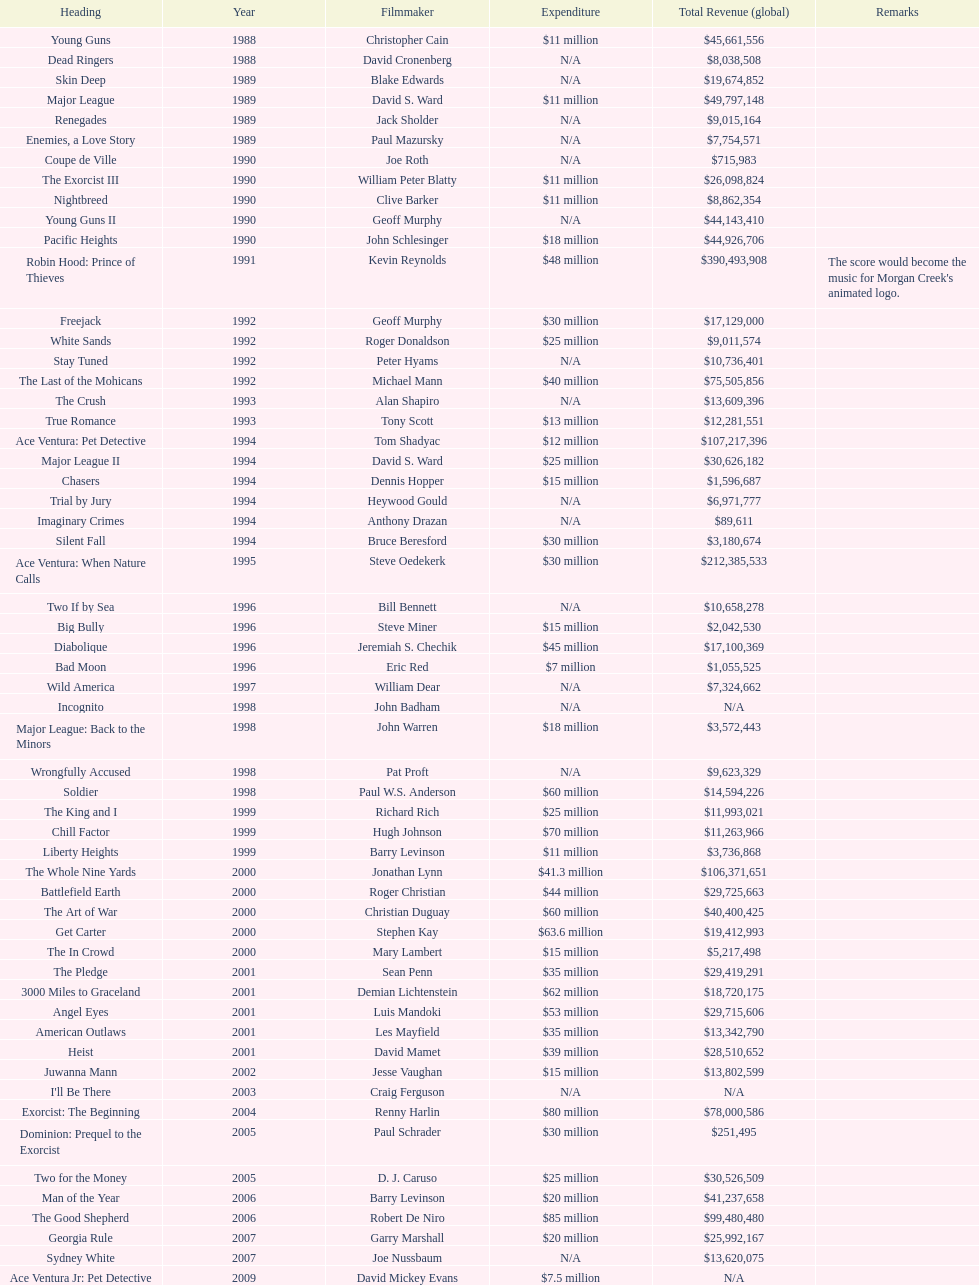What was the last movie morgan creek made for a budget under thirty million? Ace Ventura Jr: Pet Detective. 